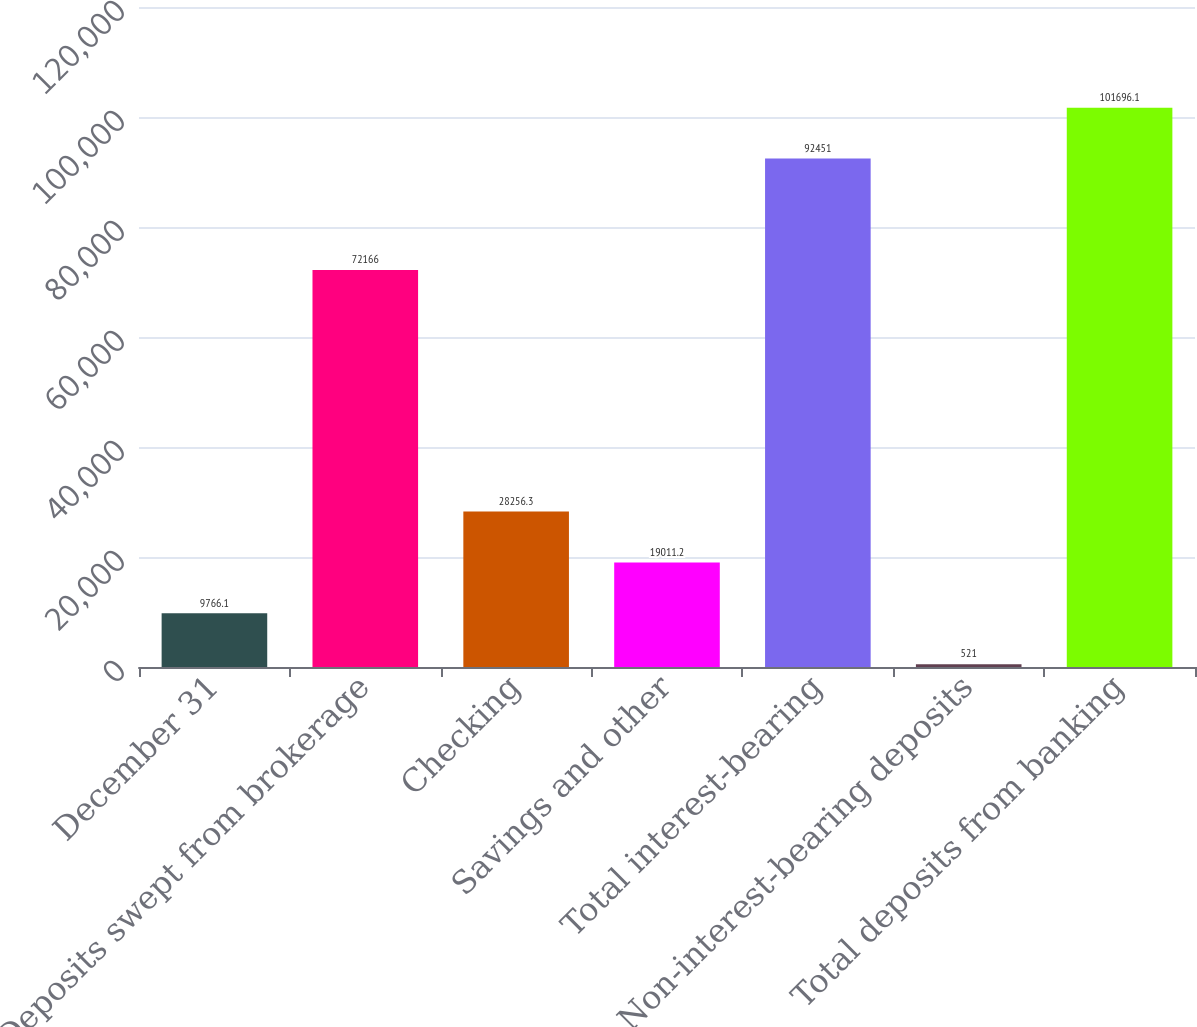Convert chart. <chart><loc_0><loc_0><loc_500><loc_500><bar_chart><fcel>December 31<fcel>Deposits swept from brokerage<fcel>Checking<fcel>Savings and other<fcel>Total interest-bearing<fcel>Non-interest-bearing deposits<fcel>Total deposits from banking<nl><fcel>9766.1<fcel>72166<fcel>28256.3<fcel>19011.2<fcel>92451<fcel>521<fcel>101696<nl></chart> 